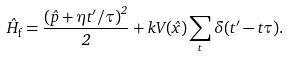<formula> <loc_0><loc_0><loc_500><loc_500>\hat { H } _ { \text {f} } = \frac { \left ( \hat { p } + \eta t ^ { \prime } / \tau \right ) ^ { 2 } } { 2 } + k V ( \hat { x } ) \sum _ { t } \delta ( t ^ { \prime } - t \tau ) .</formula> 